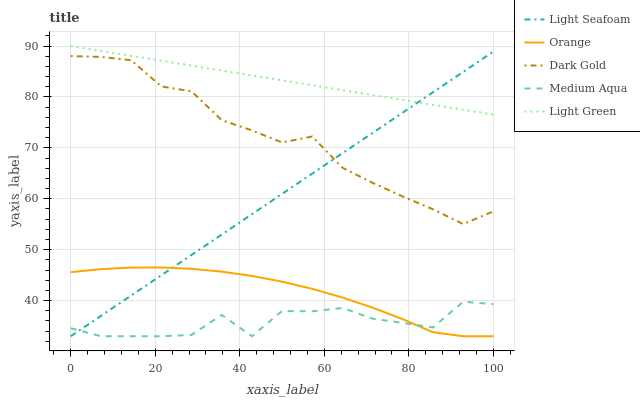Does Medium Aqua have the minimum area under the curve?
Answer yes or no. Yes. Does Light Green have the maximum area under the curve?
Answer yes or no. Yes. Does Light Seafoam have the minimum area under the curve?
Answer yes or no. No. Does Light Seafoam have the maximum area under the curve?
Answer yes or no. No. Is Light Seafoam the smoothest?
Answer yes or no. Yes. Is Medium Aqua the roughest?
Answer yes or no. Yes. Is Medium Aqua the smoothest?
Answer yes or no. No. Is Light Seafoam the roughest?
Answer yes or no. No. Does Orange have the lowest value?
Answer yes or no. Yes. Does Light Green have the lowest value?
Answer yes or no. No. Does Light Green have the highest value?
Answer yes or no. Yes. Does Light Seafoam have the highest value?
Answer yes or no. No. Is Dark Gold less than Light Green?
Answer yes or no. Yes. Is Light Green greater than Dark Gold?
Answer yes or no. Yes. Does Light Seafoam intersect Light Green?
Answer yes or no. Yes. Is Light Seafoam less than Light Green?
Answer yes or no. No. Is Light Seafoam greater than Light Green?
Answer yes or no. No. Does Dark Gold intersect Light Green?
Answer yes or no. No. 